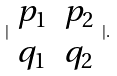<formula> <loc_0><loc_0><loc_500><loc_500>| \begin{array} { c c } p _ { 1 } & p _ { 2 } \\ q _ { 1 } & q _ { 2 } \end{array} | .</formula> 